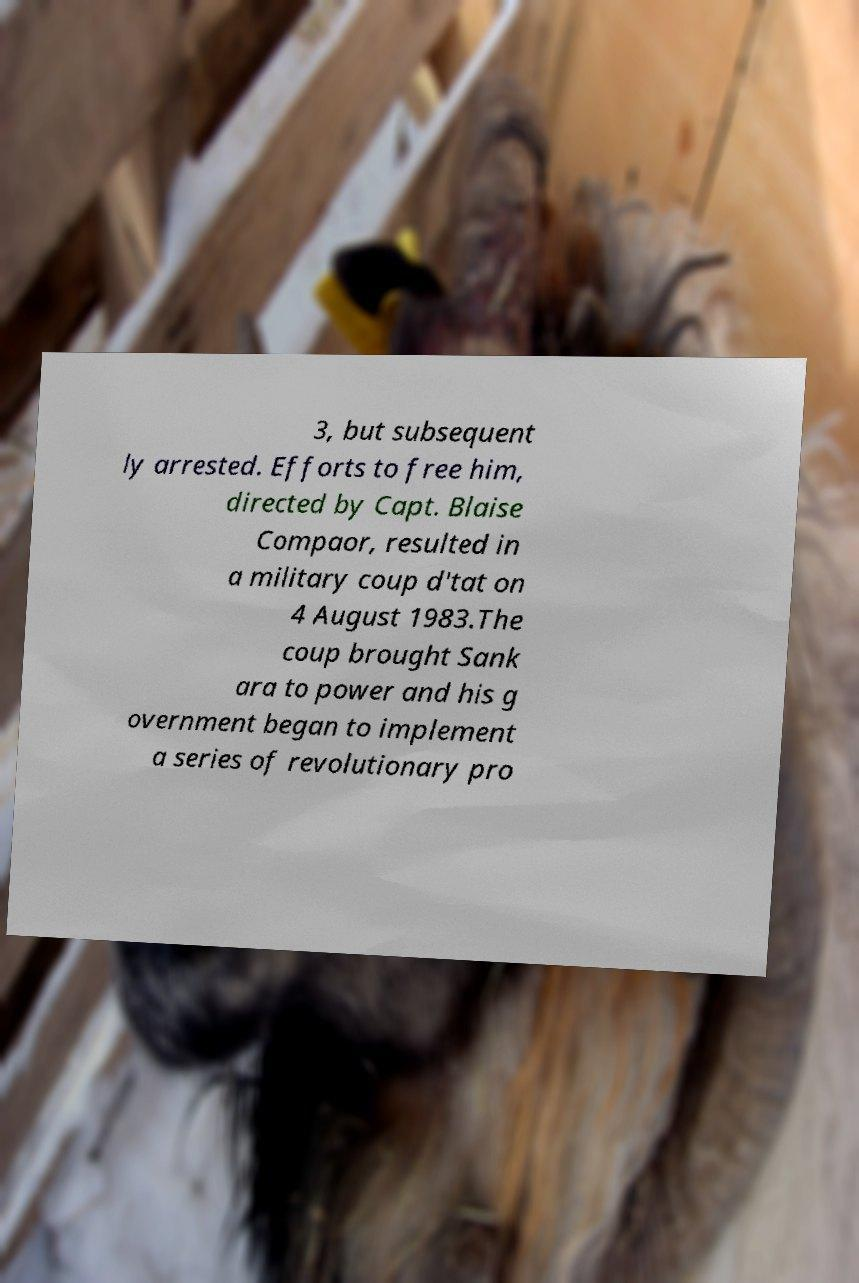Can you accurately transcribe the text from the provided image for me? 3, but subsequent ly arrested. Efforts to free him, directed by Capt. Blaise Compaor, resulted in a military coup d'tat on 4 August 1983.The coup brought Sank ara to power and his g overnment began to implement a series of revolutionary pro 